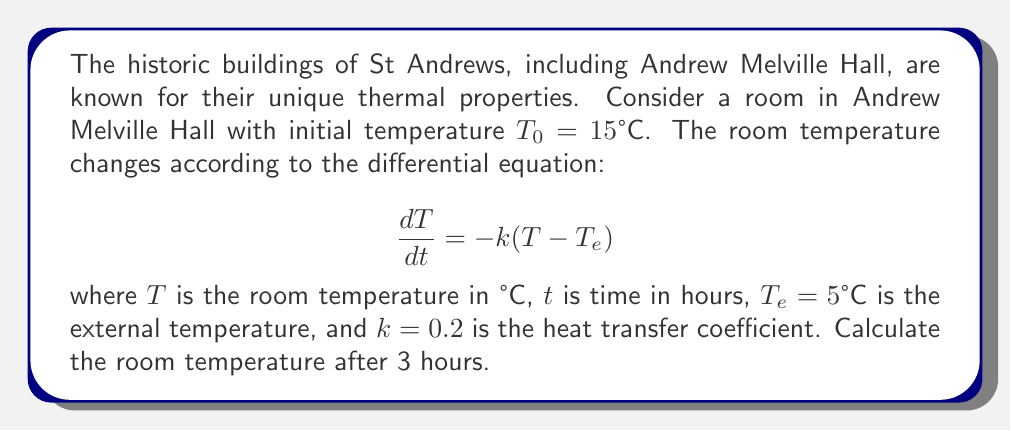Give your solution to this math problem. To solve this problem, we need to use the solution to the first-order linear differential equation:

1) The general solution to the equation $\frac{dT}{dt} = -k(T - T_e)$ is:

   $$T(t) = T_e + (T_0 - T_e)e^{-kt}$$

2) We are given:
   - Initial temperature $T_0 = 15°C$
   - External temperature $T_e = 5°C$
   - Heat transfer coefficient $k = 0.2$
   - Time $t = 3$ hours

3) Substituting these values into the general solution:

   $$T(3) = 5 + (15 - 5)e^{-0.2 \cdot 3}$$

4) Simplify:
   $$T(3) = 5 + 10e^{-0.6}$$

5) Calculate $e^{-0.6} \approx 0.5488$:
   $$T(3) = 5 + 10 \cdot 0.5488 = 5 + 5.488 = 10.488°C$$

6) Round to two decimal places:
   $$T(3) \approx 10.49°C$$
Answer: $10.49°C$ 